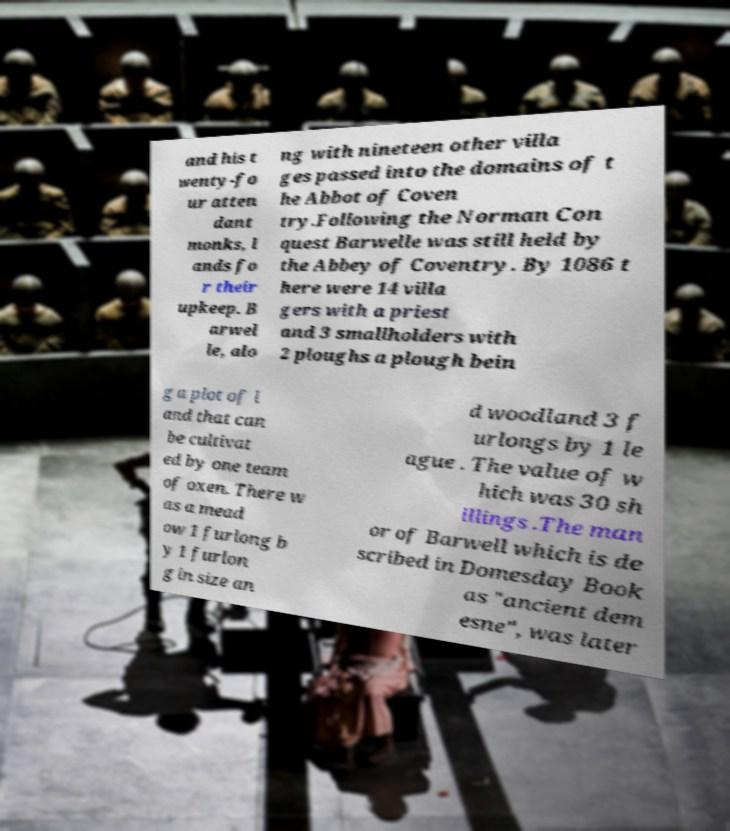Can you read and provide the text displayed in the image?This photo seems to have some interesting text. Can you extract and type it out for me? and his t wenty-fo ur atten dant monks, l ands fo r their upkeep. B arwel le, alo ng with nineteen other villa ges passed into the domains of t he Abbot of Coven try.Following the Norman Con quest Barwelle was still held by the Abbey of Coventry. By 1086 t here were 14 villa gers with a priest and 3 smallholders with 2 ploughs a plough bein g a plot of l and that can be cultivat ed by one team of oxen. There w as a mead ow 1 furlong b y 1 furlon g in size an d woodland 3 f urlongs by 1 le ague . The value of w hich was 30 sh illings .The man or of Barwell which is de scribed in Domesday Book as "ancient dem esne", was later 